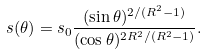Convert formula to latex. <formula><loc_0><loc_0><loc_500><loc_500>s ( \theta ) = s _ { 0 } \frac { ( \sin \theta ) ^ { 2 / ( R ^ { 2 } - 1 ) } } { ( \cos \theta ) ^ { 2 R ^ { 2 } / ( R ^ { 2 } - 1 ) } } .</formula> 